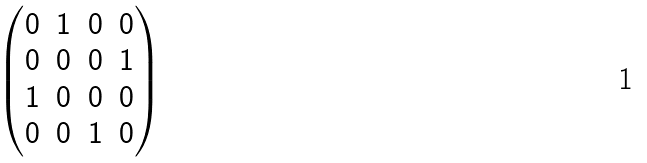<formula> <loc_0><loc_0><loc_500><loc_500>\begin{pmatrix} 0 & 1 & 0 & 0 \\ 0 & 0 & 0 & 1 \\ 1 & 0 & 0 & 0 \\ 0 & 0 & 1 & 0 \end{pmatrix}</formula> 